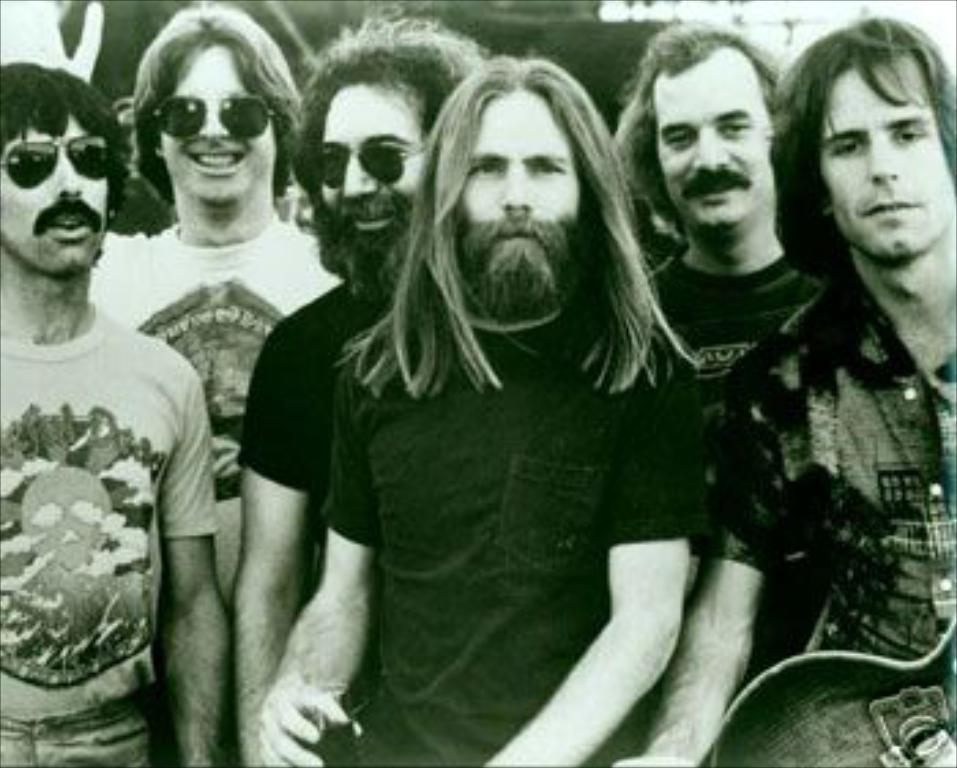What is the main subject of the image? The main subject of the image is a group of men. What are the men wearing in the image? The men are wearing t-shirts in the image. Can you describe the men on the left side of the image? Three men on the left side are wearing goggles. How many bikes are being measured by the men in the image? There are no bikes present in the image, and the men are not measuring anything. 